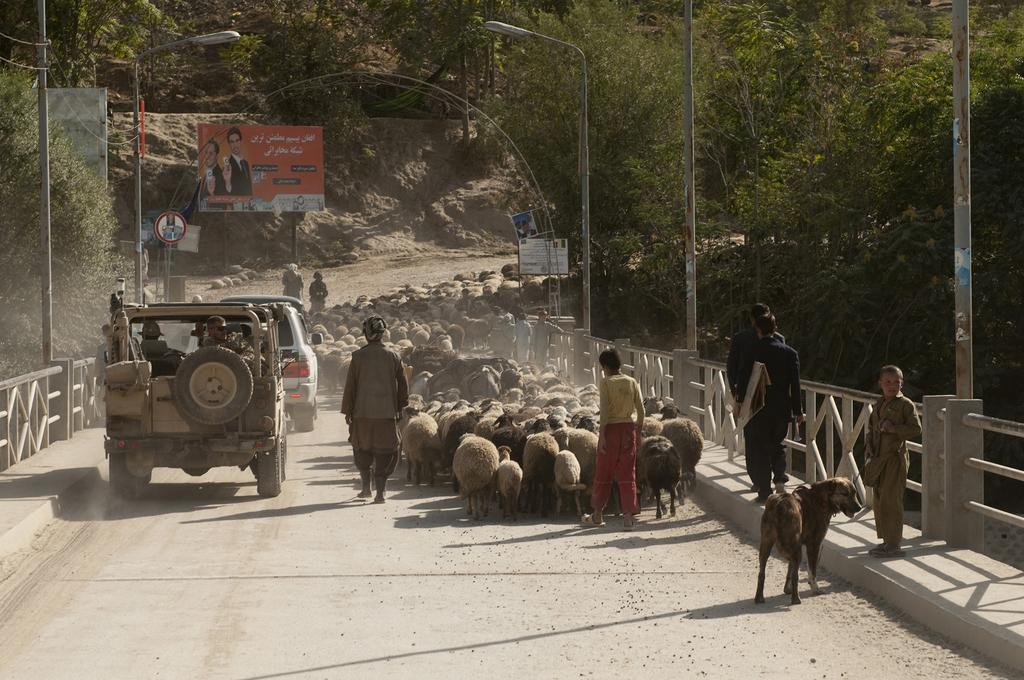What type of animals can be seen in the image? There is a flock of sheep in the image. Are there any people present in the image? Yes, there are people in the image. What else can be seen in the image besides the sheep and people? There are vehicles, trees, poles, lights, and boards in the image. Is there any other animal besides the sheep in the image? Yes, there is a dog in the image. What type of soap is being used by the people in the image? There is no soap present in the image; it features a flock of sheep, people, vehicles, trees, poles, lights, and boards. Can you describe the kiss between the sheep and the dog in the image? There is no kiss between the sheep and the dog in the image; it is a flock of sheep, people, vehicles, trees, poles, lights, and boards. 